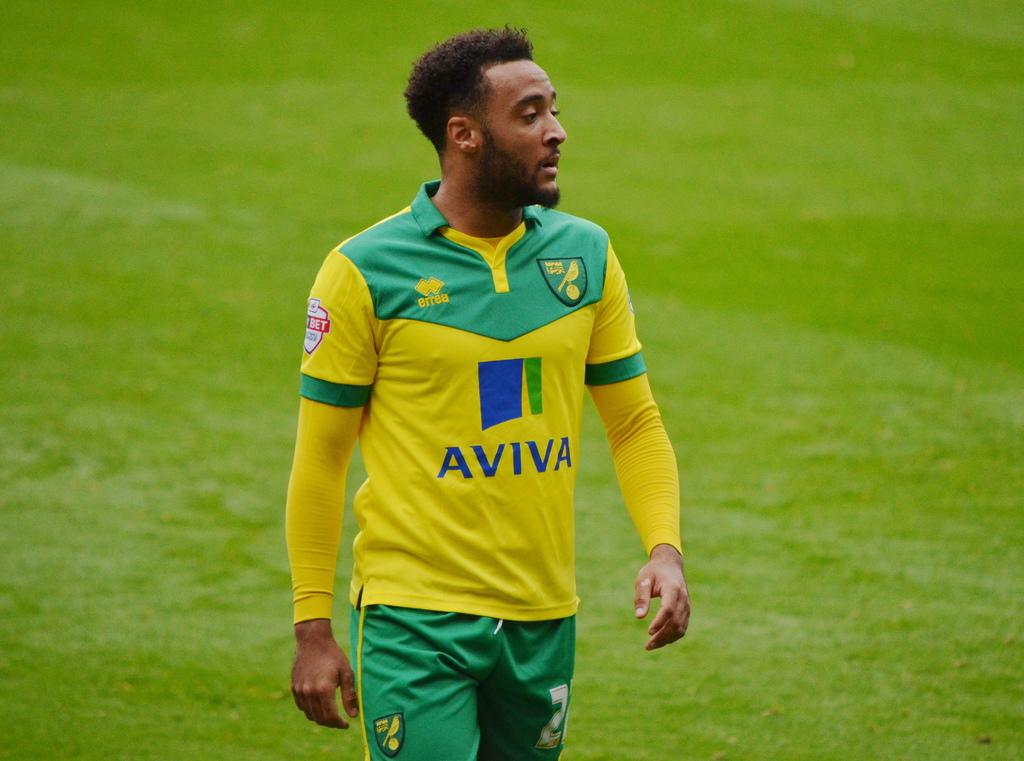What brand is the player's top?
Keep it short and to the point. Aviva. 